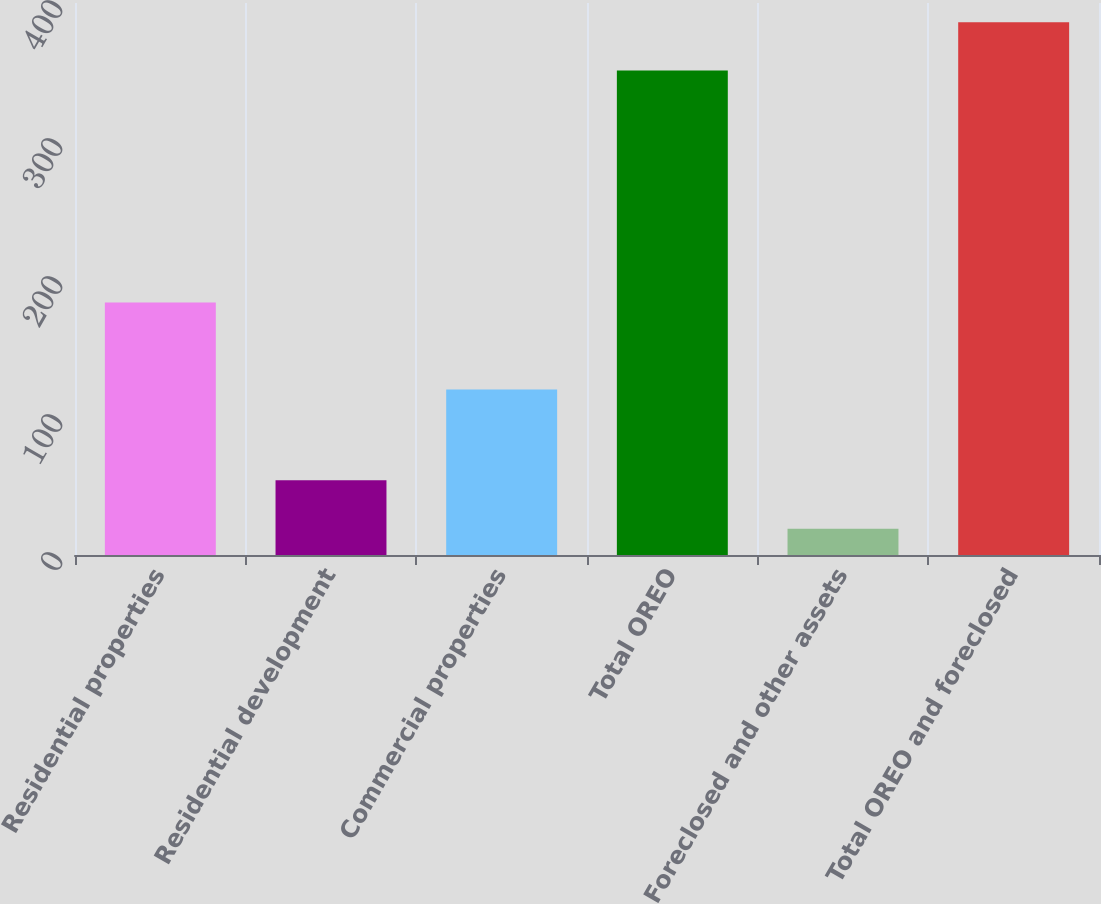<chart> <loc_0><loc_0><loc_500><loc_500><bar_chart><fcel>Residential properties<fcel>Residential development<fcel>Commercial properties<fcel>Total OREO<fcel>Foreclosed and other assets<fcel>Total OREO and foreclosed<nl><fcel>183<fcel>54.1<fcel>120<fcel>351<fcel>19<fcel>386.1<nl></chart> 